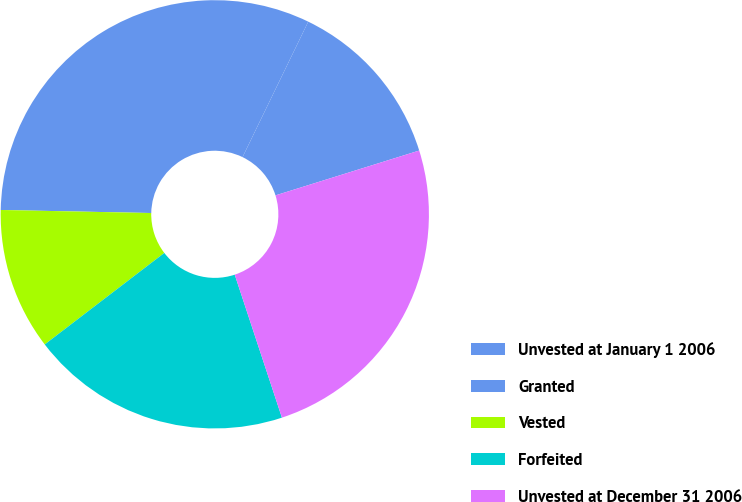Convert chart to OTSL. <chart><loc_0><loc_0><loc_500><loc_500><pie_chart><fcel>Unvested at January 1 2006<fcel>Granted<fcel>Vested<fcel>Forfeited<fcel>Unvested at December 31 2006<nl><fcel>13.0%<fcel>31.87%<fcel>10.72%<fcel>19.68%<fcel>24.74%<nl></chart> 